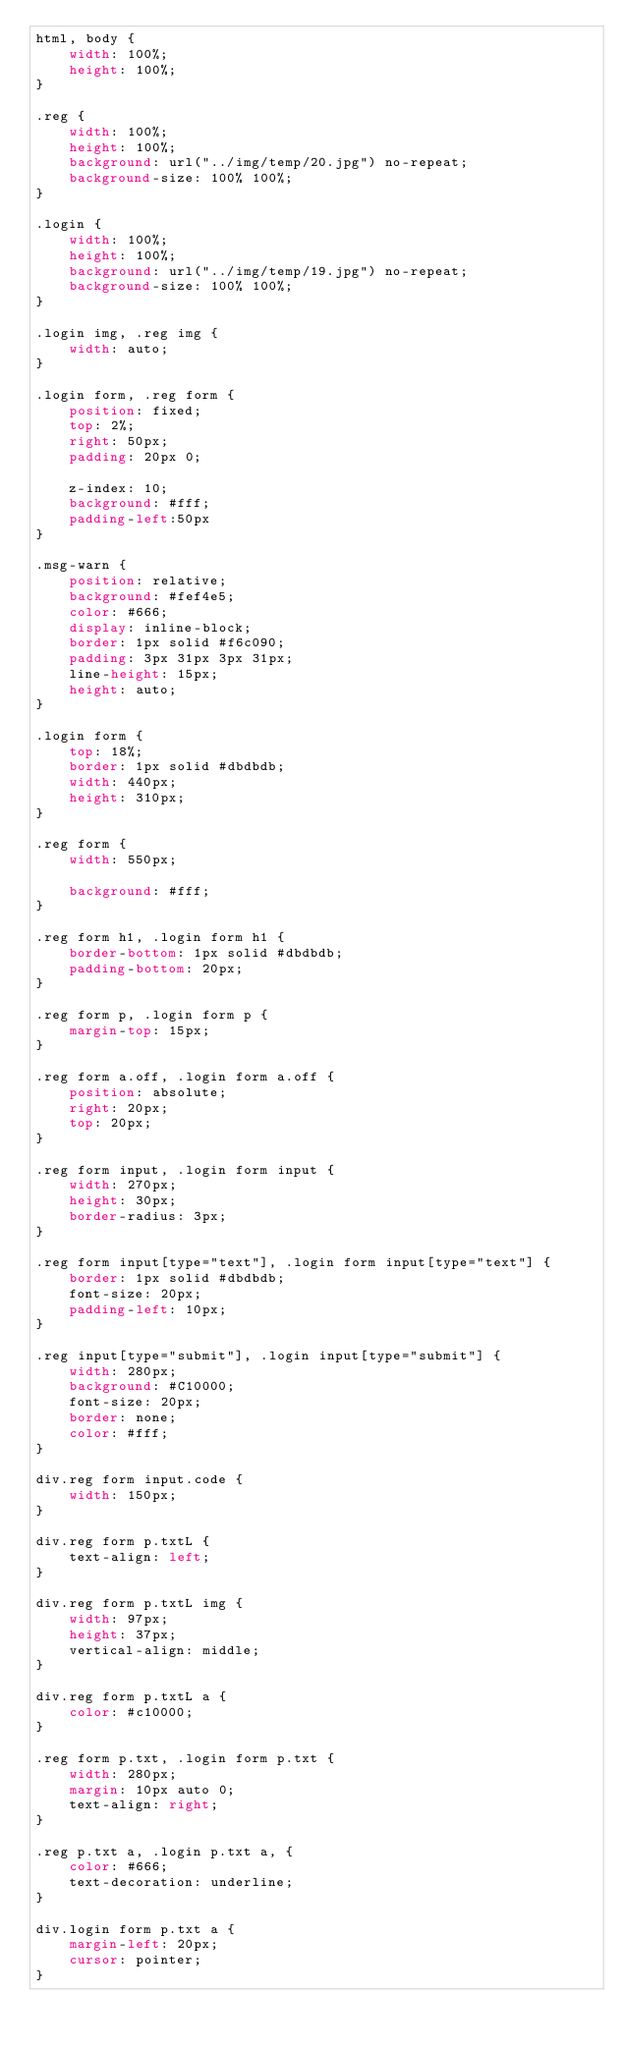<code> <loc_0><loc_0><loc_500><loc_500><_CSS_>html, body {
    width: 100%;
    height: 100%;
}

.reg {
    width: 100%;
    height: 100%;
    background: url("../img/temp/20.jpg") no-repeat;
    background-size: 100% 100%;
}

.login {
    width: 100%;
    height: 100%;
    background: url("../img/temp/19.jpg") no-repeat;
    background-size: 100% 100%;
}

.login img, .reg img {
    width: auto;
}

.login form, .reg form {
    position: fixed;
    top: 2%;
    right: 50px;
    padding: 20px 0;
    
    z-index: 10;
    background: #fff;
    padding-left:50px
}

.msg-warn {
    position: relative;
    background: #fef4e5;
    color: #666;
    display: inline-block;
    border: 1px solid #f6c090;
    padding: 3px 31px 3px 31px;
    line-height: 15px;
    height: auto;
}

.login form {
    top: 18%;
    border: 1px solid #dbdbdb;
    width: 440px;
    height: 310px;
}

.reg form {
    width: 550px;

    background: #fff;
}

.reg form h1, .login form h1 {
    border-bottom: 1px solid #dbdbdb;
    padding-bottom: 20px;
}

.reg form p, .login form p {
    margin-top: 15px;
}

.reg form a.off, .login form a.off {
    position: absolute;
    right: 20px;
    top: 20px;
}

.reg form input, .login form input {
    width: 270px;
    height: 30px;
    border-radius: 3px;
}

.reg form input[type="text"], .login form input[type="text"] {
    border: 1px solid #dbdbdb;
    font-size: 20px;
    padding-left: 10px;
}

.reg input[type="submit"], .login input[type="submit"] {
    width: 280px;
    background: #C10000;
    font-size: 20px;
    border: none;
    color: #fff;
}

div.reg form input.code {
    width: 150px;
}

div.reg form p.txtL {
    text-align: left;
}

div.reg form p.txtL img {
    width: 97px;
    height: 37px;
    vertical-align: middle;
}

div.reg form p.txtL a {
    color: #c10000;
}

.reg form p.txt, .login form p.txt {
    width: 280px;
    margin: 10px auto 0;
    text-align: right;
}

.reg p.txt a, .login p.txt a, {
    color: #666;
    text-decoration: underline;
}

div.login form p.txt a {
    margin-left: 20px;
    cursor: pointer;
}</code> 